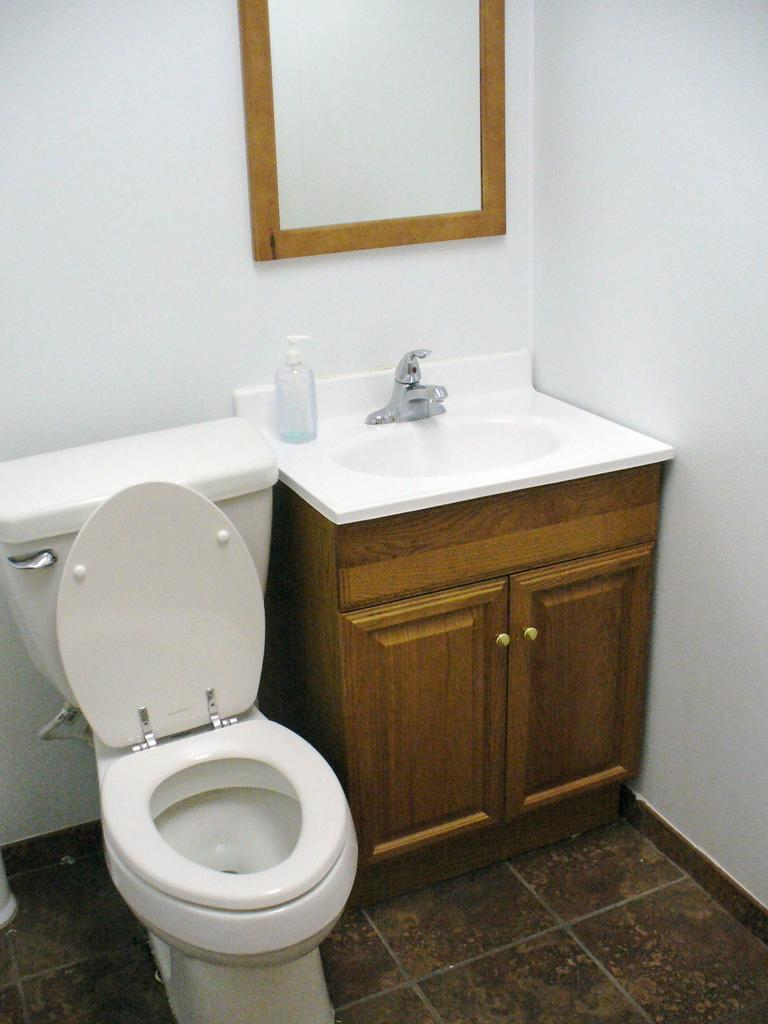What type of surface is visible in the image? There is a floor in the image. What is the primary fixture in the image? There is a toilet seat in the image. What is used to flush the toilet in the image? There is a flush tank in the image. What type of storage is present in the image? There are cupboards in the image. What is used for washing hands in the image? There is a sink in the image. What is used to control the flow of water in the sink? There is a tap in the image. What is placed on the floor in the image? There is a bottle in the image. What is present in the background of the image? There is a mirror and walls in the background of the image. How does the zipper on the toilet seat work in the image? There is no zipper present on the toilet seat in the image. What is the rate of expansion of the walls in the image? The rate of expansion of the walls is not mentioned in the image. Is there a fire visible in the image? There is no fire present in the image. 